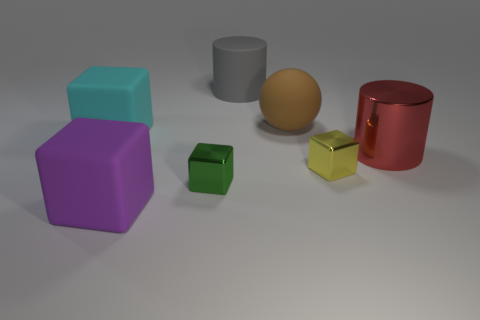How many blue objects are rubber cubes or small blocks?
Keep it short and to the point. 0. What number of small metal objects are both left of the gray cylinder and to the right of the gray rubber thing?
Provide a short and direct response. 0. Do the tiny yellow thing and the red object have the same material?
Offer a very short reply. Yes. There is a purple rubber thing that is the same size as the brown rubber object; what shape is it?
Your answer should be very brief. Cube. Are there more big red metal cylinders than big rubber objects?
Give a very brief answer. No. What is the material of the large object that is both in front of the cyan thing and to the left of the large red cylinder?
Your answer should be very brief. Rubber. What number of other things are the same material as the ball?
Make the answer very short. 3. What number of shiny cylinders are the same color as the big matte ball?
Ensure brevity in your answer.  0. There is a thing left of the purple block in front of the big matte object that is behind the large brown sphere; what size is it?
Give a very brief answer. Large. How many matte objects are cyan cubes or small yellow balls?
Make the answer very short. 1. 